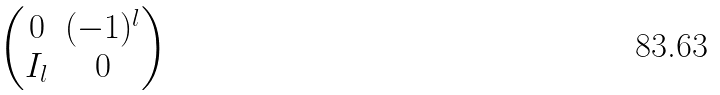<formula> <loc_0><loc_0><loc_500><loc_500>\begin{pmatrix} 0 & ( - 1 ) ^ { l } \\ I _ { l } & 0 \end{pmatrix}</formula> 